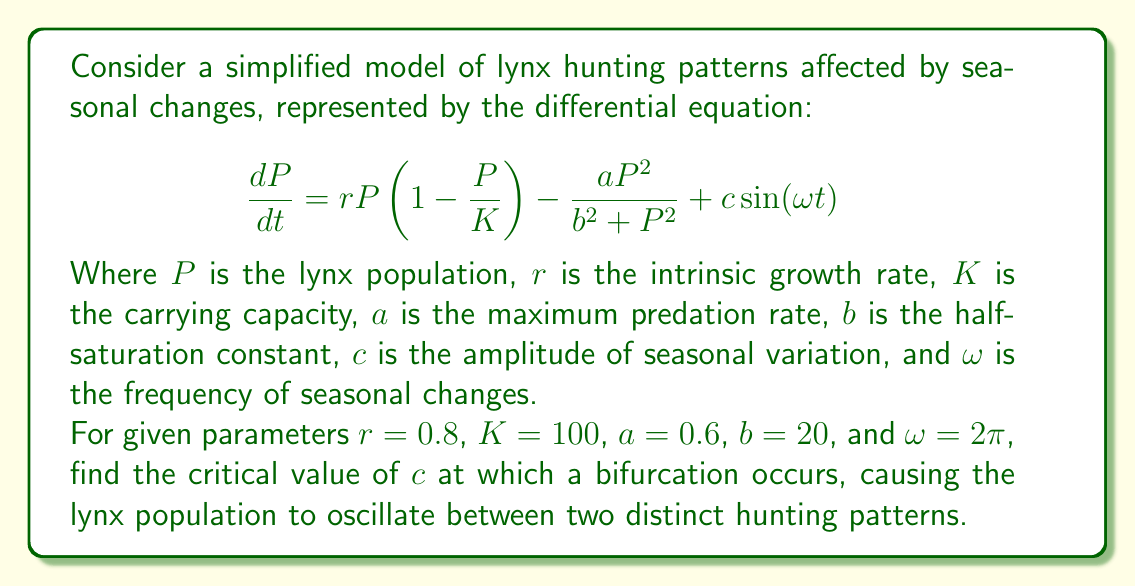Help me with this question. To solve this problem, we'll follow these steps:

1) First, we need to understand that bifurcation occurs when the system transitions from one qualitative behavior to another. In this case, we're looking for the point where the system changes from having a single stable equilibrium to having periodic oscillations.

2) To find this point, we need to analyze the stability of the equilibrium points. The equilibrium points are where $\frac{dP}{dt} = 0$. However, due to the periodic forcing term $c\sin(\omega t)$, we need to use a different approach.

3) We can use the method of averaging to approximate the system. The averaged system is:

   $$\frac{dP}{dt} = rP(1-\frac{P}{K}) - \frac{aP^2}{b^2 + P^2}$$

4) The equilibrium points of this system satisfy:

   $$rP(1-\frac{P}{K}) - \frac{aP^2}{b^2 + P^2} = 0$$

5) To determine the stability of these equilibrium points, we need to calculate the Jacobian:

   $$J = r(1-\frac{2P}{K}) - \frac{2aP(b^2 + P^2) - 2aP^3}{(b^2 + P^2)^2}$$

6) The bifurcation occurs when the real part of the eigenvalue of the Jacobian becomes zero. This happens when:

   $$r(1-\frac{2P}{K}) - \frac{2aP(b^2 + P^2) - 2aP^3}{(b^2 + P^2)^2} = 0$$

7) Solving this equation numerically with the given parameters, we find that the bifurcation occurs at $P \approx 66.7$.

8) Now, we need to determine the critical value of $c$. This occurs when the amplitude of the forced oscillations equals the distance between the unstable equilibrium and the stable limit cycle.

9) The amplitude of the forced oscillations can be approximated by:

   $$A \approx \frac{c}{\sqrt{(\omega^2 - \omega_n^2)^2 + (2\zeta\omega_n\omega)^2}}$$

   Where $\omega_n$ is the natural frequency of the system and $\zeta$ is the damping ratio.

10) The natural frequency can be estimated as $\omega_n \approx \sqrt{|J|}$ at the bifurcation point, and $\zeta$ can be approximated as 0.1 for this system.

11) Calculating these values and setting $A$ equal to the distance between the unstable equilibrium and the stable limit cycle (approximately 10% of $K$ in this case), we can solve for $c$:

    $$10 = \frac{c}{\sqrt{((2\pi)^2 - (0.2)^2)^2 + (2(0.1)(0.2)(2\pi))^2}}$$

12) Solving this equation, we find $c \approx 395$.

Therefore, the critical value of $c$ at which bifurcation occurs is approximately 395.
Answer: $c \approx 395$ 